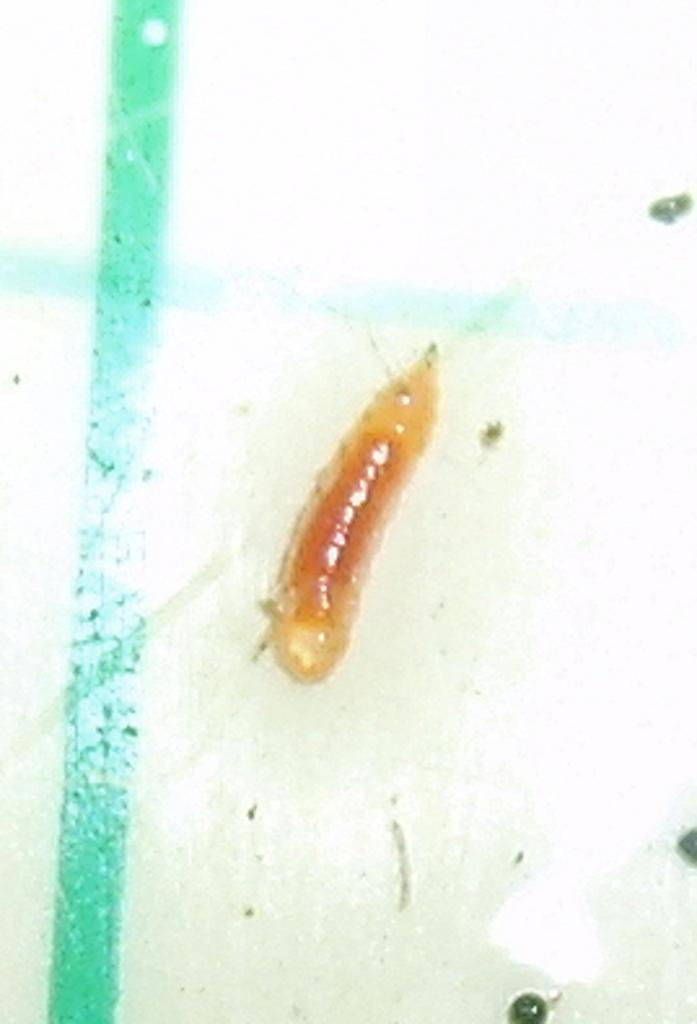What type of creature is present in the image? There is an insect in the image. What type of amusement can be seen in the image involving a squirrel? There is no squirrel or amusement present in the image; it only features an insect. What is the weight of the insect in the image? The weight of the insect cannot be determined from the image alone, as it is not possible to accurately estimate the weight of an insect based on a photograph. 